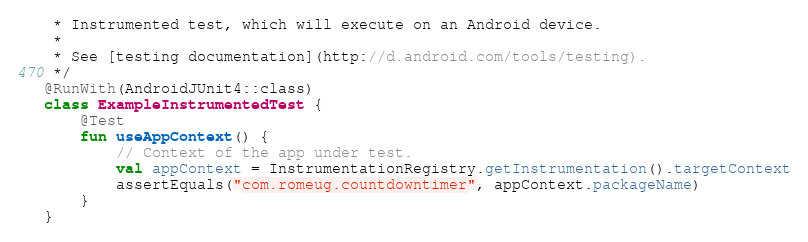Convert code to text. <code><loc_0><loc_0><loc_500><loc_500><_Kotlin_> * Instrumented test, which will execute on an Android device.
 *
 * See [testing documentation](http://d.android.com/tools/testing).
 */
@RunWith(AndroidJUnit4::class)
class ExampleInstrumentedTest {
    @Test
    fun useAppContext() {
        // Context of the app under test.
        val appContext = InstrumentationRegistry.getInstrumentation().targetContext
        assertEquals("com.romeug.countdowntimer", appContext.packageName)
    }
}</code> 